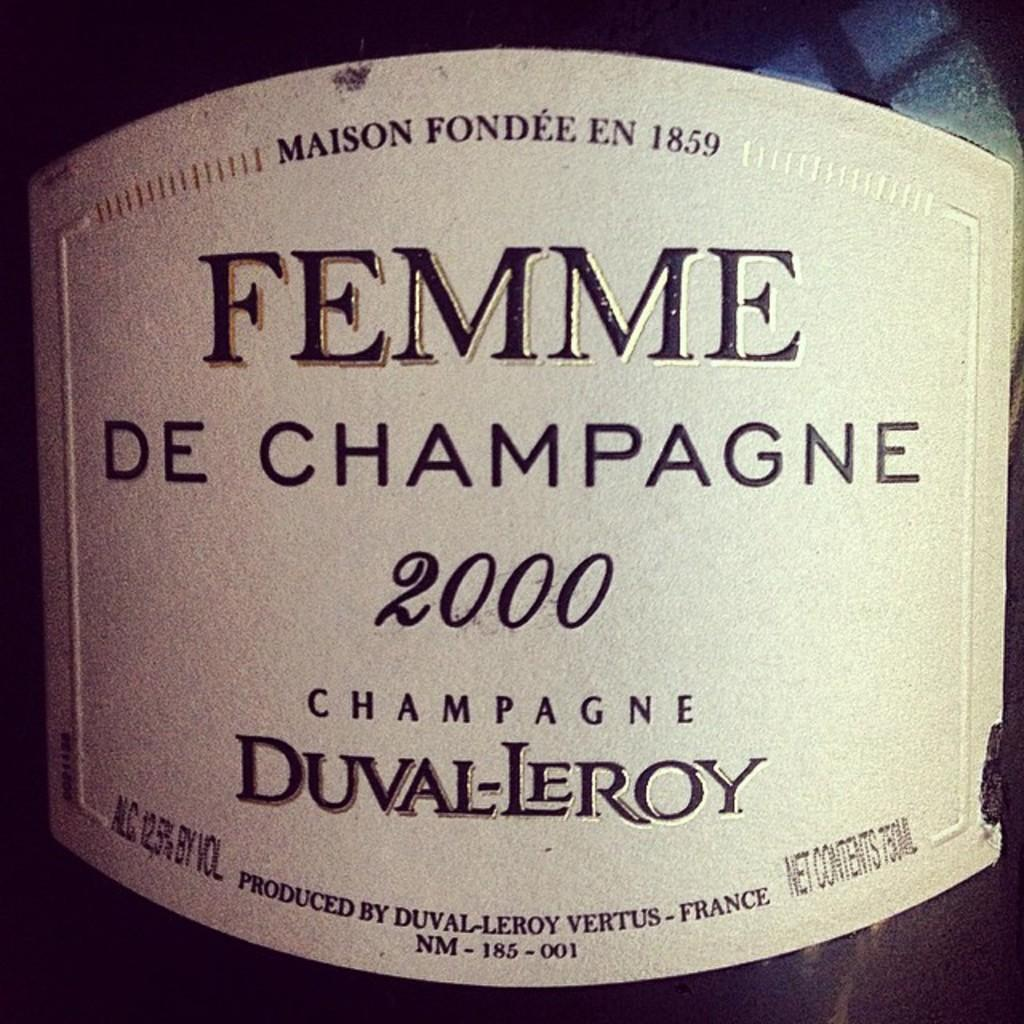Provide a one-sentence caption for the provided image. The bottle of Femme de champagne was produced in France. 